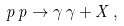Convert formula to latex. <formula><loc_0><loc_0><loc_500><loc_500>p \, p \rightarrow \gamma \, \gamma + X \, ,</formula> 